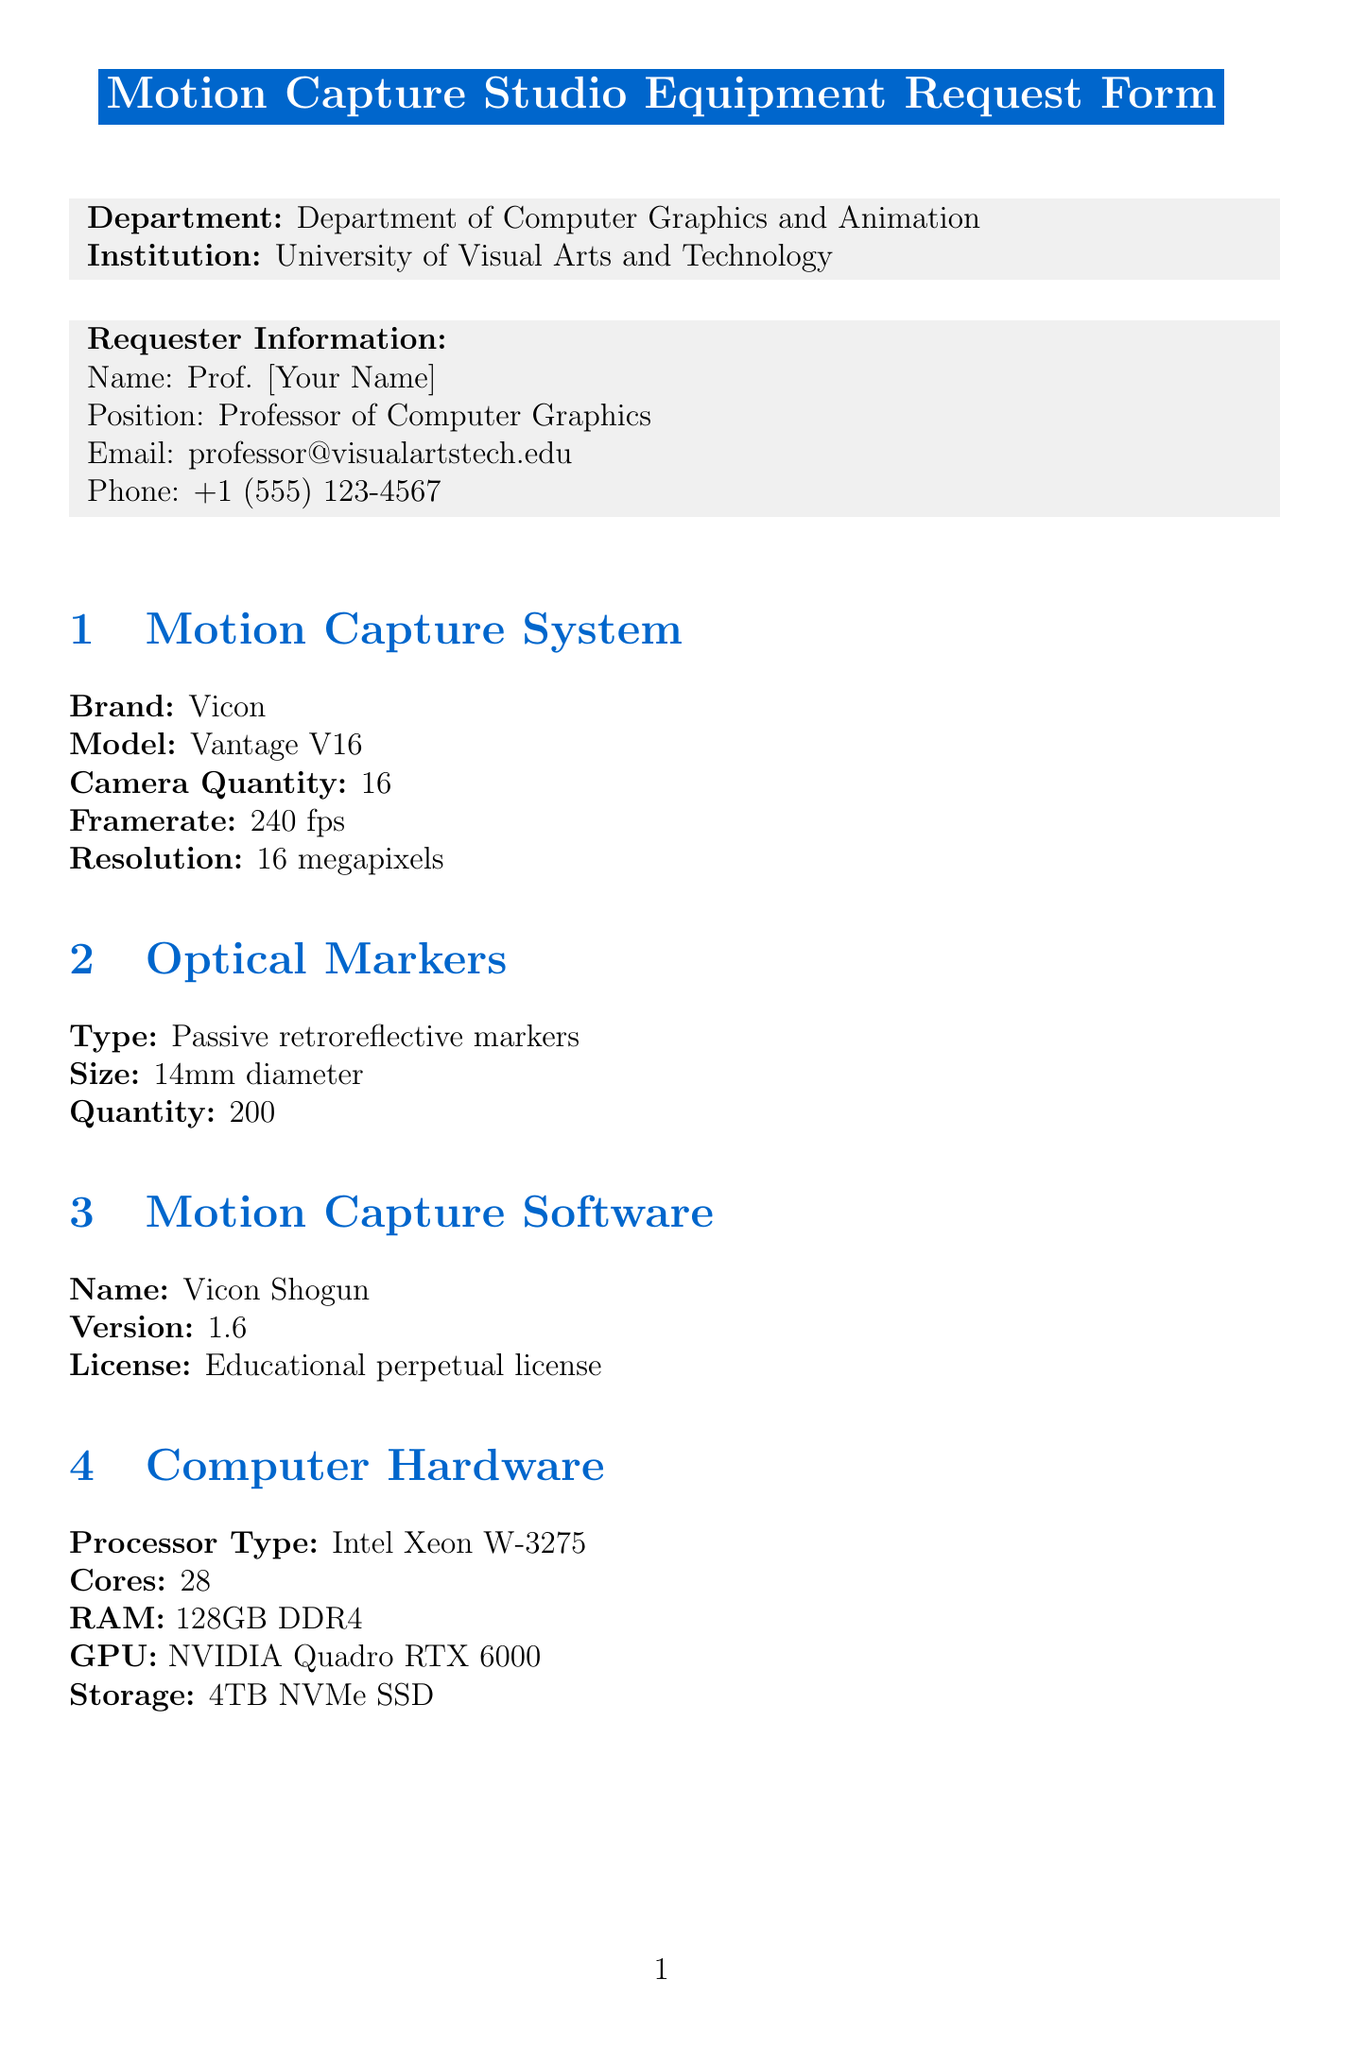What is the brand of the motion capture system? The brand of the motion capture system is listed in the document under the Motion Capture System section.
Answer: Vicon How many cameras are included in the motion capture system? The document specifies the camera quantity in the Motion Capture System section.
Answer: 16 What is the resolution of the cameras? The resolution is detailed in the Motion Capture System section of the document.
Answer: 16 megapixels What is the budget estimate for the computer hardware? The budget for computer hardware is provided in the Budget Estimate section, detailing the cost of various items.
Answer: $15,000 What room requirements are specified for installation? Installation requirements can be found in the Installation Requirements section, listing necessary features for the space.
Answer: Dedicated room with controlled lighting Which software is mentioned for 3D animation? The software for 3D animation is listed in the Post-Processing Software section.
Answer: Autodesk Maya How many mocap suits are requested? The quantity of mocap suits is specified in the Additional Equipment section of the document.
Answer: 5 Who is the department head approving the request? The document lists the name of the department head in the Approval section.
Answer: Dr. Emily Renderer What is the total cost estimate for all equipment? The total budget estimate is calculated and presented in the Budget Estimate section of the document.
Answer: $195,000 